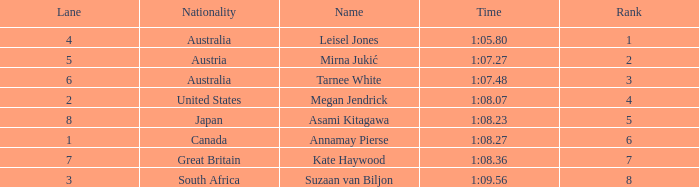What is the Nationality of the Swimmer in Lane 4 or larger with a Rank of 5 or more? Great Britain. 